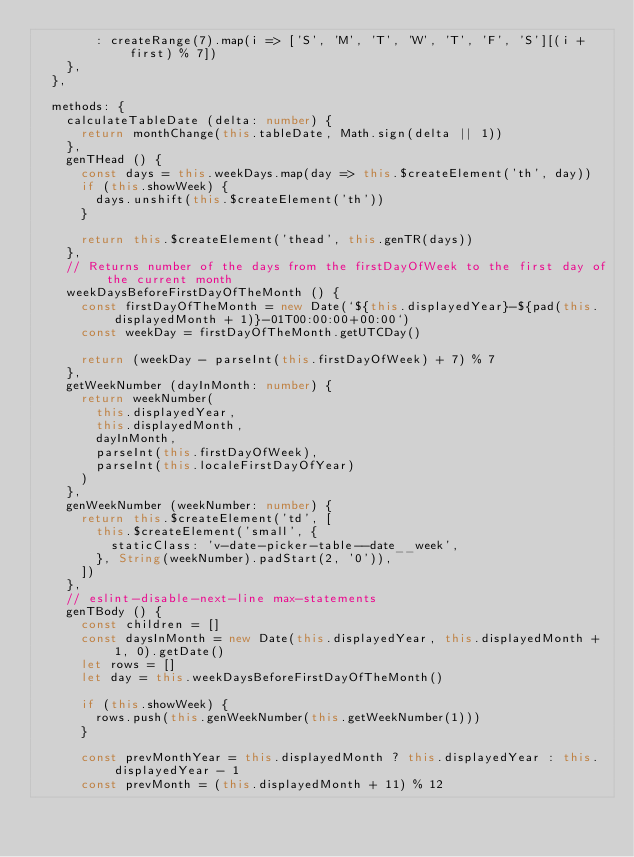<code> <loc_0><loc_0><loc_500><loc_500><_TypeScript_>        : createRange(7).map(i => ['S', 'M', 'T', 'W', 'T', 'F', 'S'][(i + first) % 7])
    },
  },

  methods: {
    calculateTableDate (delta: number) {
      return monthChange(this.tableDate, Math.sign(delta || 1))
    },
    genTHead () {
      const days = this.weekDays.map(day => this.$createElement('th', day))
      if (this.showWeek) {
        days.unshift(this.$createElement('th'))
      }

      return this.$createElement('thead', this.genTR(days))
    },
    // Returns number of the days from the firstDayOfWeek to the first day of the current month
    weekDaysBeforeFirstDayOfTheMonth () {
      const firstDayOfTheMonth = new Date(`${this.displayedYear}-${pad(this.displayedMonth + 1)}-01T00:00:00+00:00`)
      const weekDay = firstDayOfTheMonth.getUTCDay()

      return (weekDay - parseInt(this.firstDayOfWeek) + 7) % 7
    },
    getWeekNumber (dayInMonth: number) {
      return weekNumber(
        this.displayedYear,
        this.displayedMonth,
        dayInMonth,
        parseInt(this.firstDayOfWeek),
        parseInt(this.localeFirstDayOfYear)
      )
    },
    genWeekNumber (weekNumber: number) {
      return this.$createElement('td', [
        this.$createElement('small', {
          staticClass: 'v-date-picker-table--date__week',
        }, String(weekNumber).padStart(2, '0')),
      ])
    },
    // eslint-disable-next-line max-statements
    genTBody () {
      const children = []
      const daysInMonth = new Date(this.displayedYear, this.displayedMonth + 1, 0).getDate()
      let rows = []
      let day = this.weekDaysBeforeFirstDayOfTheMonth()

      if (this.showWeek) {
        rows.push(this.genWeekNumber(this.getWeekNumber(1)))
      }

      const prevMonthYear = this.displayedMonth ? this.displayedYear : this.displayedYear - 1
      const prevMonth = (this.displayedMonth + 11) % 12</code> 